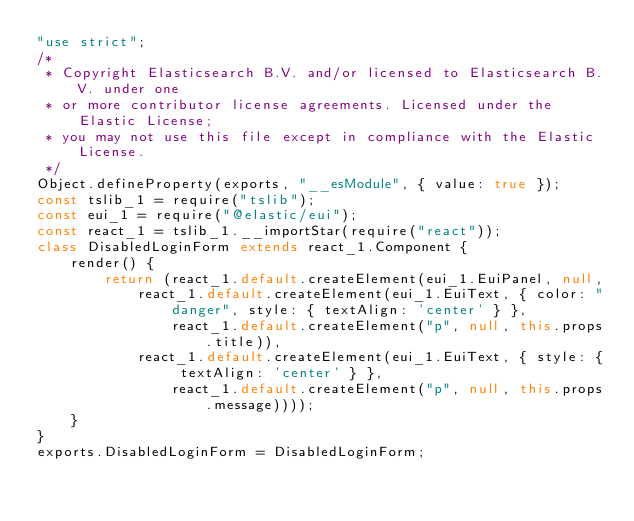<code> <loc_0><loc_0><loc_500><loc_500><_JavaScript_>"use strict";
/*
 * Copyright Elasticsearch B.V. and/or licensed to Elasticsearch B.V. under one
 * or more contributor license agreements. Licensed under the Elastic License;
 * you may not use this file except in compliance with the Elastic License.
 */
Object.defineProperty(exports, "__esModule", { value: true });
const tslib_1 = require("tslib");
const eui_1 = require("@elastic/eui");
const react_1 = tslib_1.__importStar(require("react"));
class DisabledLoginForm extends react_1.Component {
    render() {
        return (react_1.default.createElement(eui_1.EuiPanel, null,
            react_1.default.createElement(eui_1.EuiText, { color: "danger", style: { textAlign: 'center' } },
                react_1.default.createElement("p", null, this.props.title)),
            react_1.default.createElement(eui_1.EuiText, { style: { textAlign: 'center' } },
                react_1.default.createElement("p", null, this.props.message))));
    }
}
exports.DisabledLoginForm = DisabledLoginForm;
</code> 